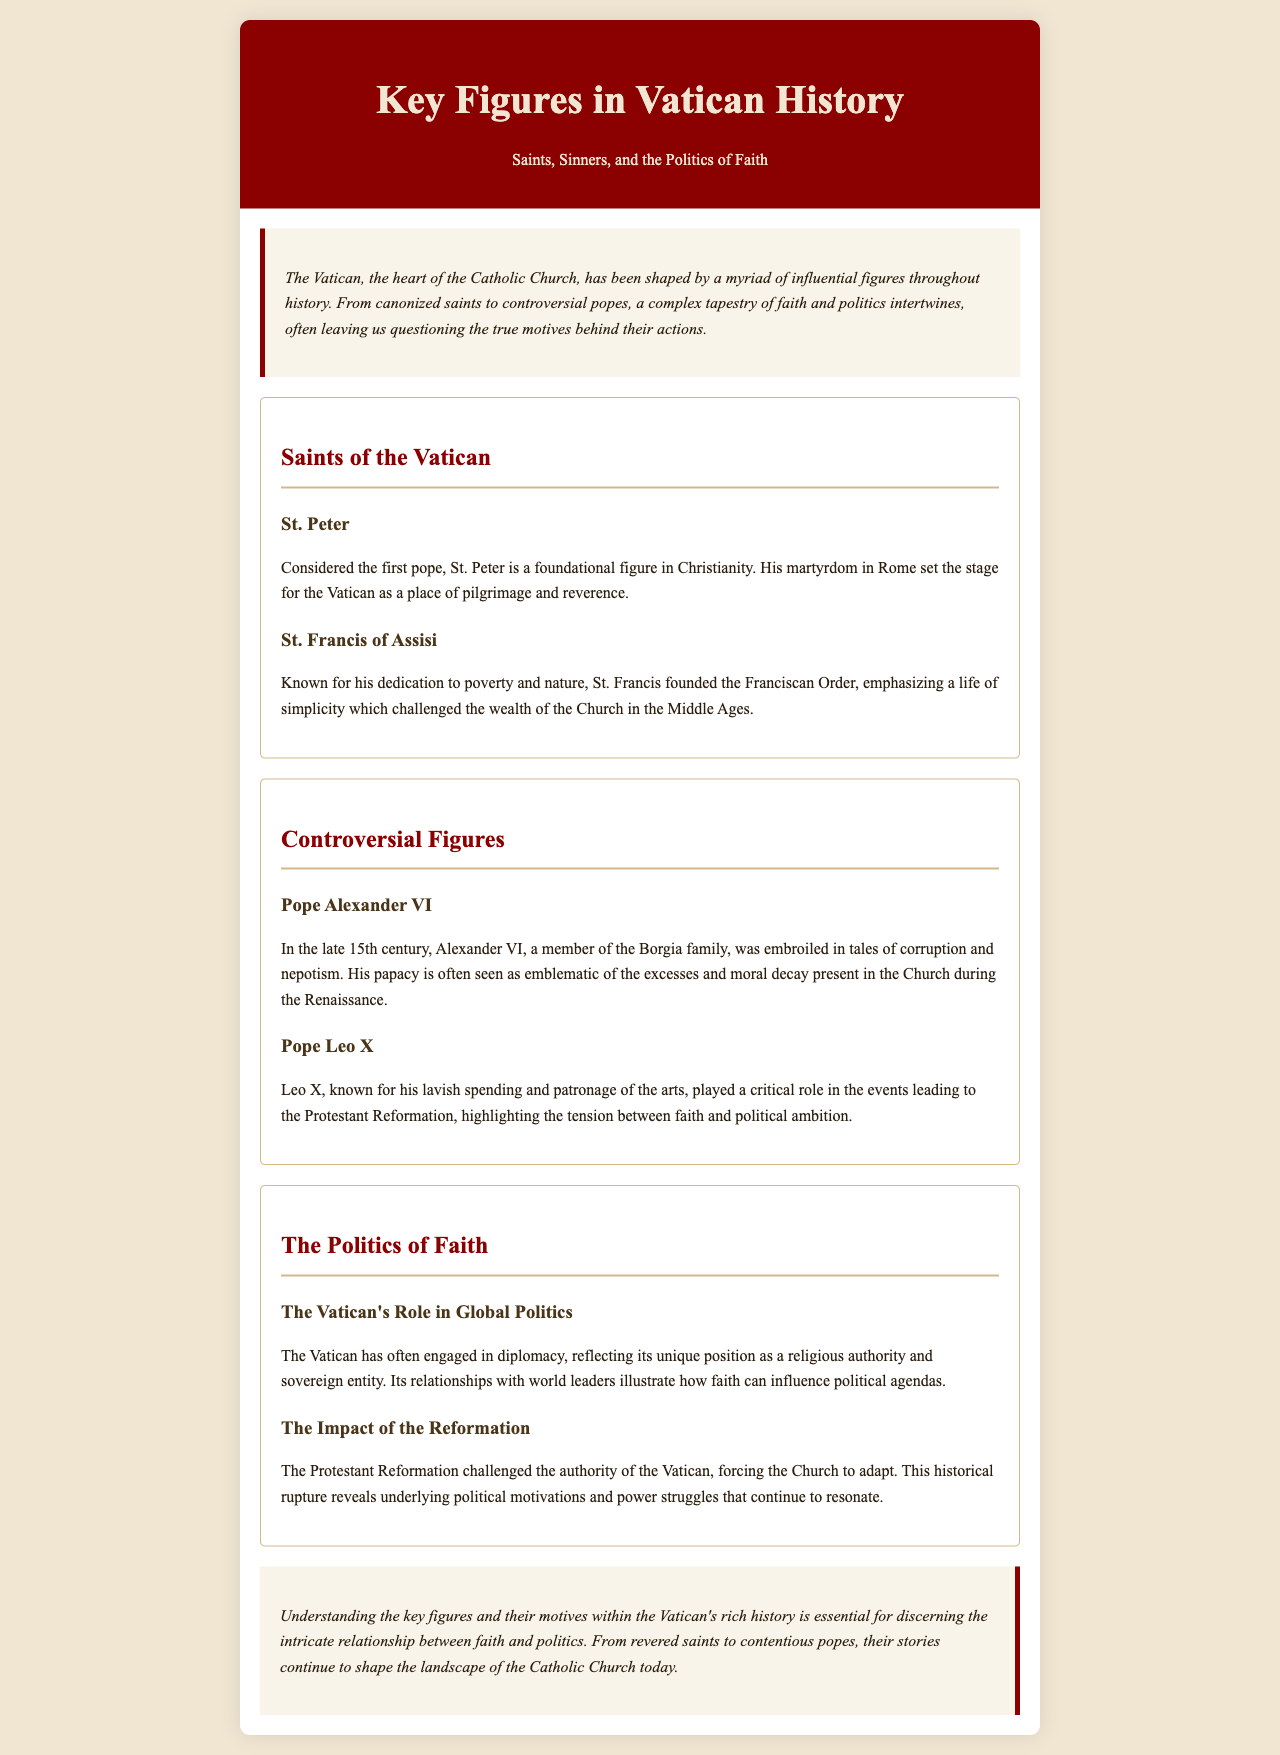What role is St. Peter known for? St. Peter is considered the first pope, which is a foundational role in Christianity.
Answer: first pope Who founded the Franciscan Order? St. Francis of Assisi is known for founding the Franciscan Order.
Answer: St. Francis of Assisi Which pope was a member of the Borgia family? Pope Alexander VI was embroiled in tales of corruption and was a member of the Borgia family.
Answer: Pope Alexander VI What significant event did Pope Leo X contribute to? Pope Leo X played a critical role in the events leading to the Protestant Reformation.
Answer: Protestant Reformation What was the Vatican's unique position in global politics? The Vatican has engaged in diplomacy as both a religious authority and a sovereign entity.
Answer: religious authority and sovereign entity What was a consequence of the Protestant Reformation for the Vatican? The Reformation challenged the authority of the Vatican, forcing the Church to adapt.
Answer: challenged authority What is noted as a defining feature of Pope Alexander VI's papacy? His papacy is often seen as emblematic of the excesses and moral decay present in the Church.
Answer: excesses and moral decay How does the document describe the relationship between faith and politics? The document indicates that understanding key figures is essential for discerning the intricate relationship between faith and politics.
Answer: intricate relationship What is the main theme of the brochure? The brochure's main theme revolves around saints, sinners, and the politics of faith in Vatican history.
Answer: saints, sinners, and the politics of faith 